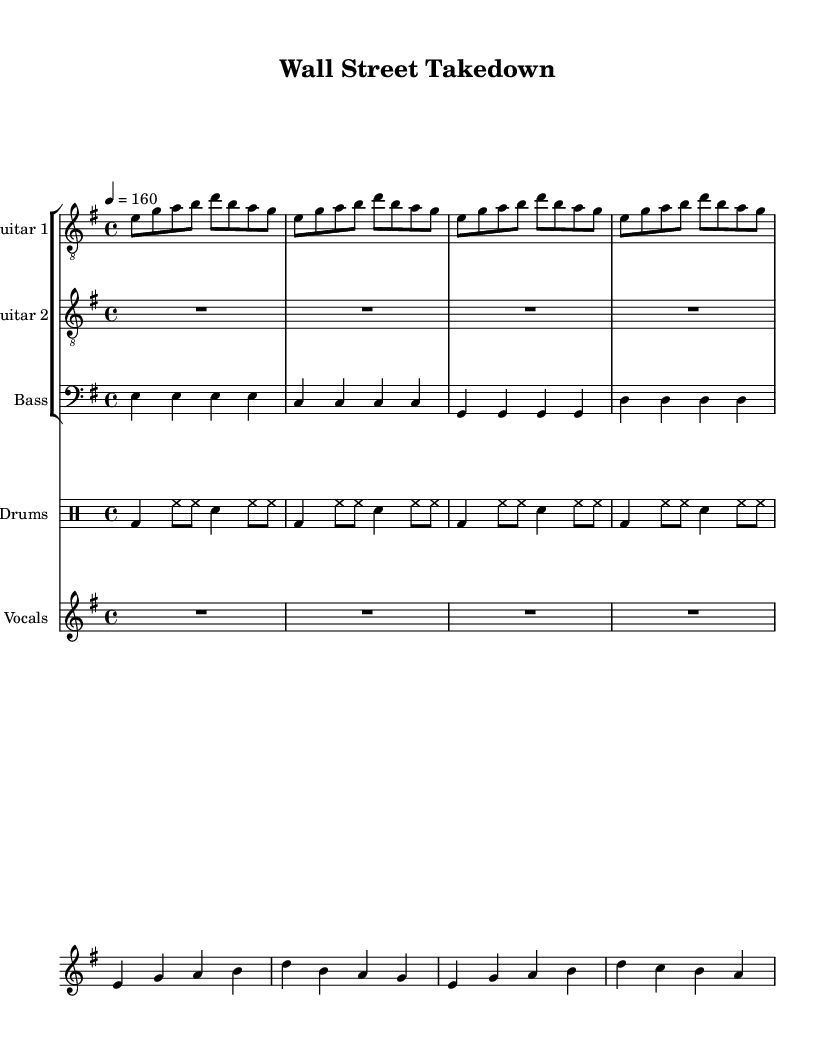What is the key signature of this music? The key signature is E minor, which has one sharp (F#). This can be identified at the beginning of the staff where the sharp sign is located on the F line.
Answer: E minor What is the time signature of this music? The time signature is 4/4, indicated at the beginning of the score where two numbers are placed, with the upper number being 4 and the lower number also being 4. This means four beats per measure with a quarter note receiving one beat.
Answer: 4/4 What is the tempo marking for this piece? The tempo marking is quarter note equals 160, shown after the time signature. This indicates that there should be 160 beats per minute, which is a fast tempo typical for metal music.
Answer: 160 How many measures are in the guitar section? There are four measures in the guitar section, which can be calculated by counting the groups of notes divided by bar lines; each group corresponds to a measure, and there are four visible in that section.
Answer: 4 What instruments are included in this score? The instruments in this score include Guitar 1, Guitar 2, Bass, Drums, and Vocals. This is determined by examining the staff labels above each section, which clearly state the name of the instrument.
Answer: Guitar 1, Guitar 2, Bass, Drums, Vocals What are the first two words of the lyrics? The first two words of the lyrics are "Cor rupt," which can be found beneath the staff for Vocals. The lyrics are aligned under the notes, and the first word is "Cor," followed by "rupt."
Answer: Cor rupt What is the predominant theme of the lyrics? The predominant theme of the lyrics is justice against corrupt executives. This can be inferred from the words like "Corrupt execs" and "Justice comes swiftly," reflecting a narrative focused on accountability and moral justice.
Answer: Justice against corrupt executives 